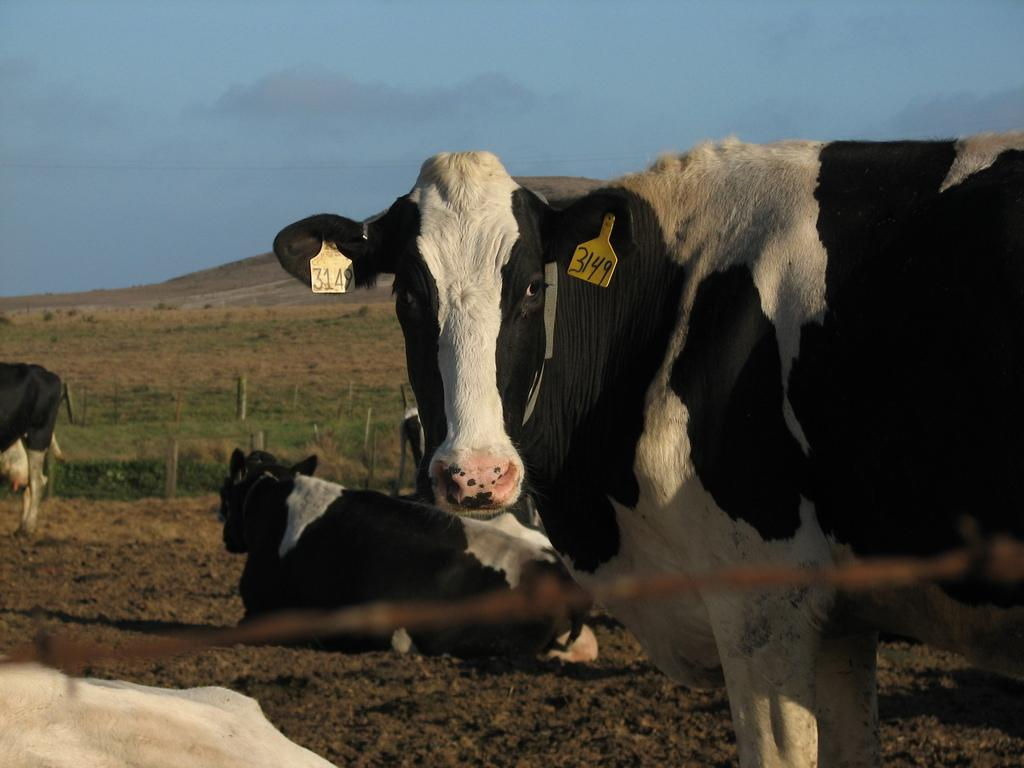What animals are present in the image? There is a group of cows in the image. What can be seen in the background of the image? There is a fence, grass, mountains, and the sky visible in the background of the image. What type of terrain is at the bottom of the image? There is sand at the bottom of the image. What type of amusement park can be seen in the image? There is no amusement park present in the image; it features a group of cows and natural elements like grass, mountains, and sand. 